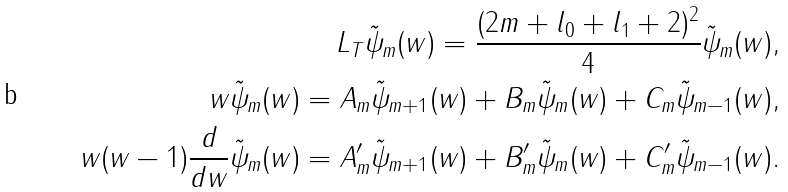<formula> <loc_0><loc_0><loc_500><loc_500>L _ { T } \tilde { \psi } _ { m } ( w ) = \frac { ( 2 m + l _ { 0 } + l _ { 1 } + 2 ) ^ { 2 } } { 4 } \tilde { \psi } _ { m } ( w ) , \\ w \tilde { \psi } _ { m } ( w ) = A _ { m } \tilde { \psi } _ { m + 1 } ( w ) + B _ { m } \tilde { \psi } _ { m } ( w ) + C _ { m } \tilde { \psi } _ { m - 1 } ( w ) , \\ w ( w - 1 ) \frac { d } { d w } \tilde { \psi } _ { m } ( w ) = A ^ { \prime } _ { m } \tilde { \psi } _ { m + 1 } ( w ) + B ^ { \prime } _ { m } \tilde { \psi } _ { m } ( w ) + C ^ { \prime } _ { m } \tilde { \psi } _ { m - 1 } ( w ) .</formula> 